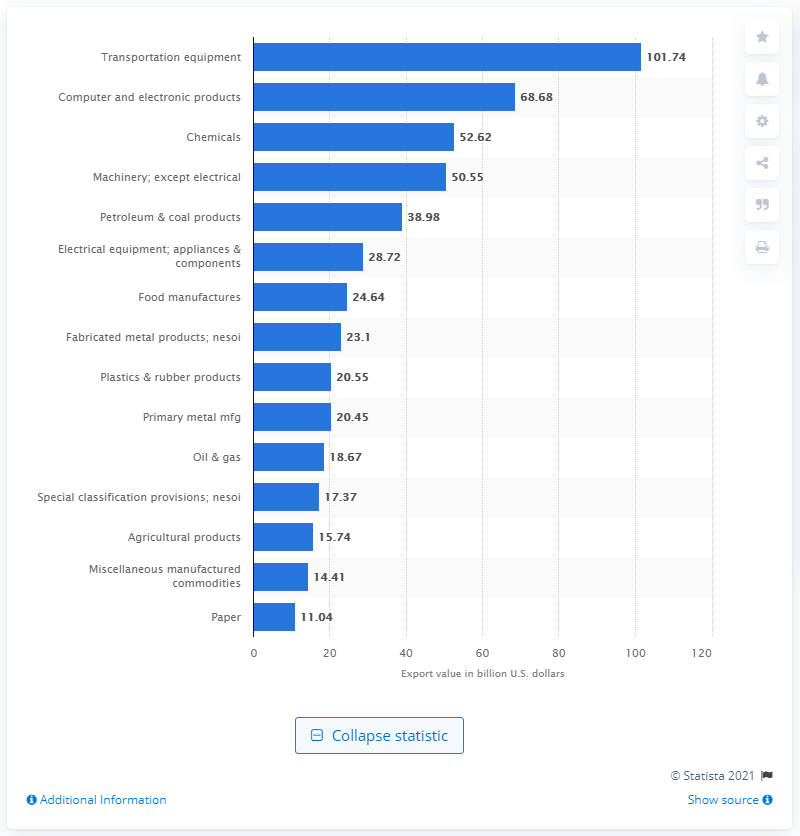Outline some significant characteristics in this image. In 2019, a total of $52.62 million worth of chemicals were exported to NAFTA members. 